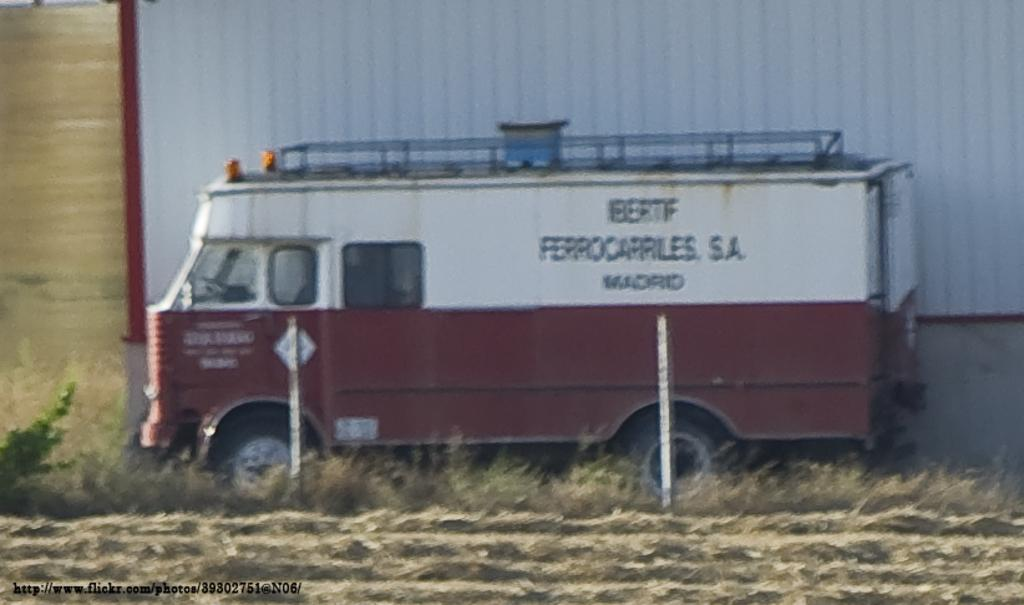What is the main subject of the image? There is a vehicle in the image. What is the vehicle doing in the image? The vehicle is moving on the land. What else can be seen in the image besides the vehicle? There are poles and grass visible in the image. What type of clam is being used as a food source in the image? There is no clam or food source present in the image; it features a vehicle moving on the land with poles and grass in the background. What is the zinc content of the grass in the image? There is no information about the zinc content of the grass in the image, as it is not relevant to the description of the image. 